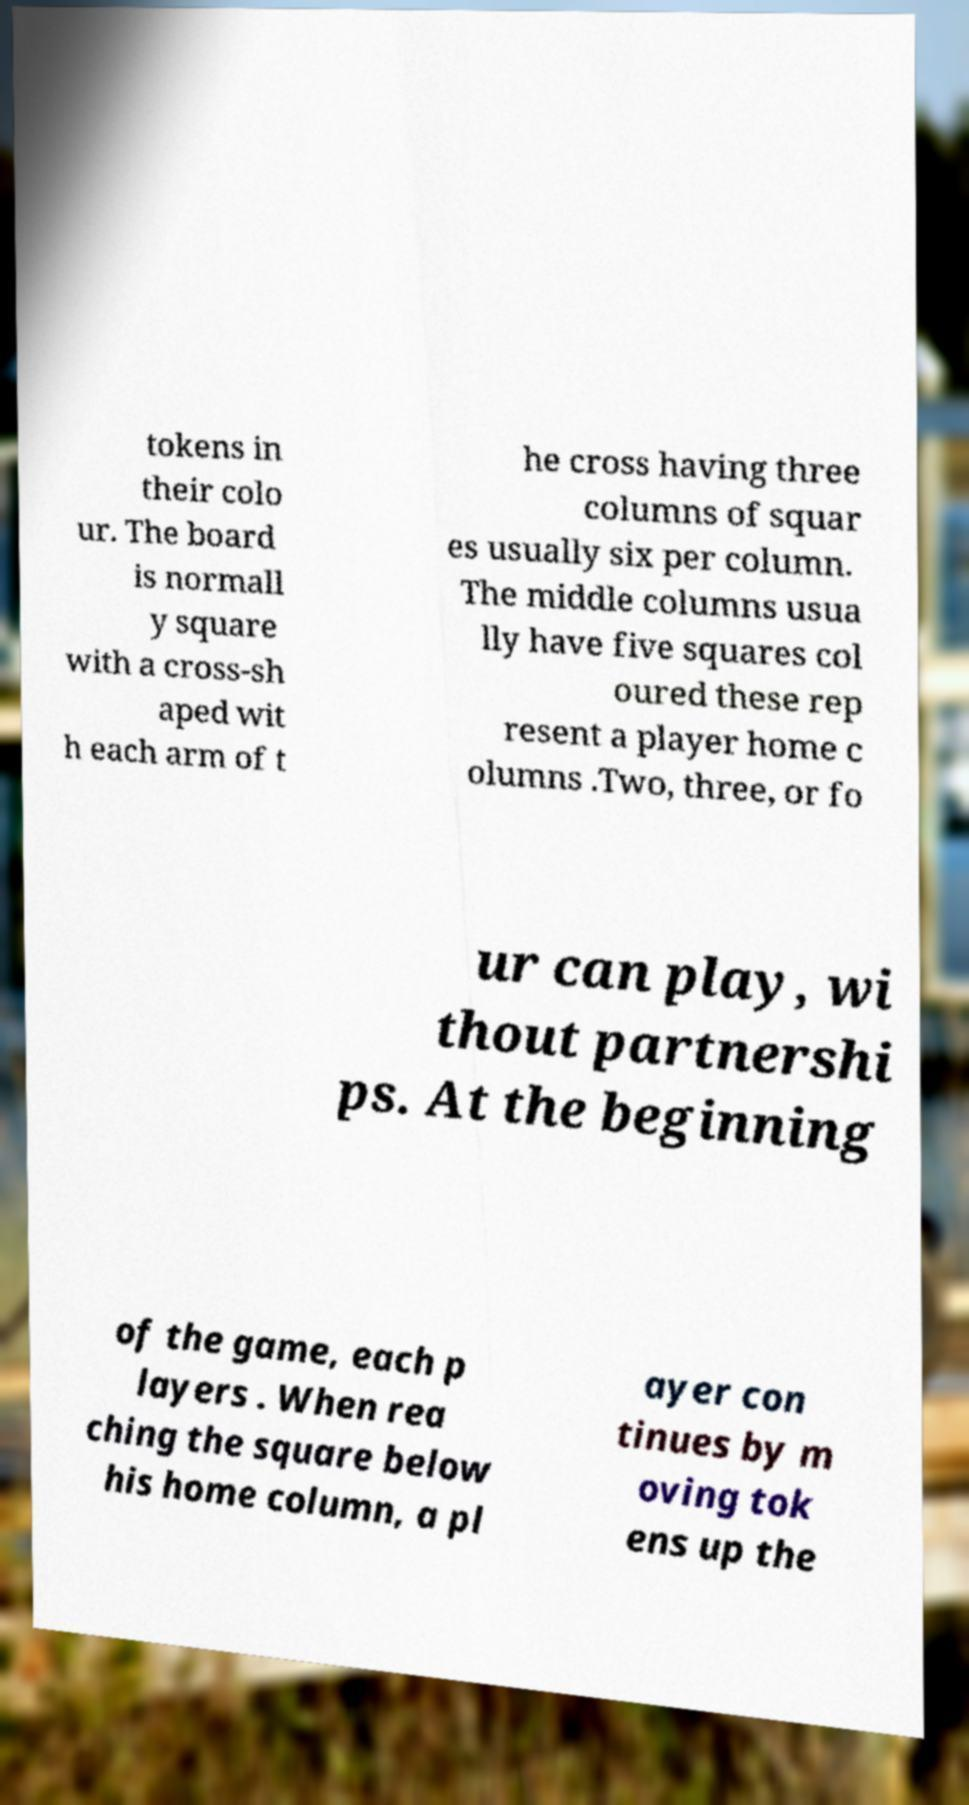Please read and relay the text visible in this image. What does it say? tokens in their colo ur. The board is normall y square with a cross-sh aped wit h each arm of t he cross having three columns of squar es usually six per column. The middle columns usua lly have five squares col oured these rep resent a player home c olumns .Two, three, or fo ur can play, wi thout partnershi ps. At the beginning of the game, each p layers . When rea ching the square below his home column, a pl ayer con tinues by m oving tok ens up the 